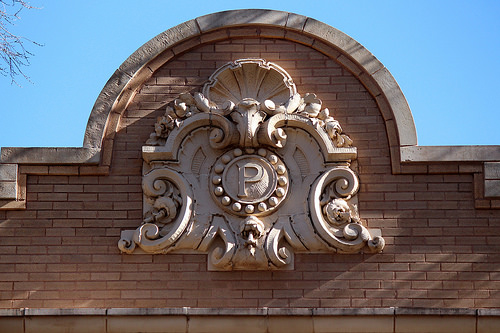<image>
Is there a letter above the wall? No. The letter is not positioned above the wall. The vertical arrangement shows a different relationship. 